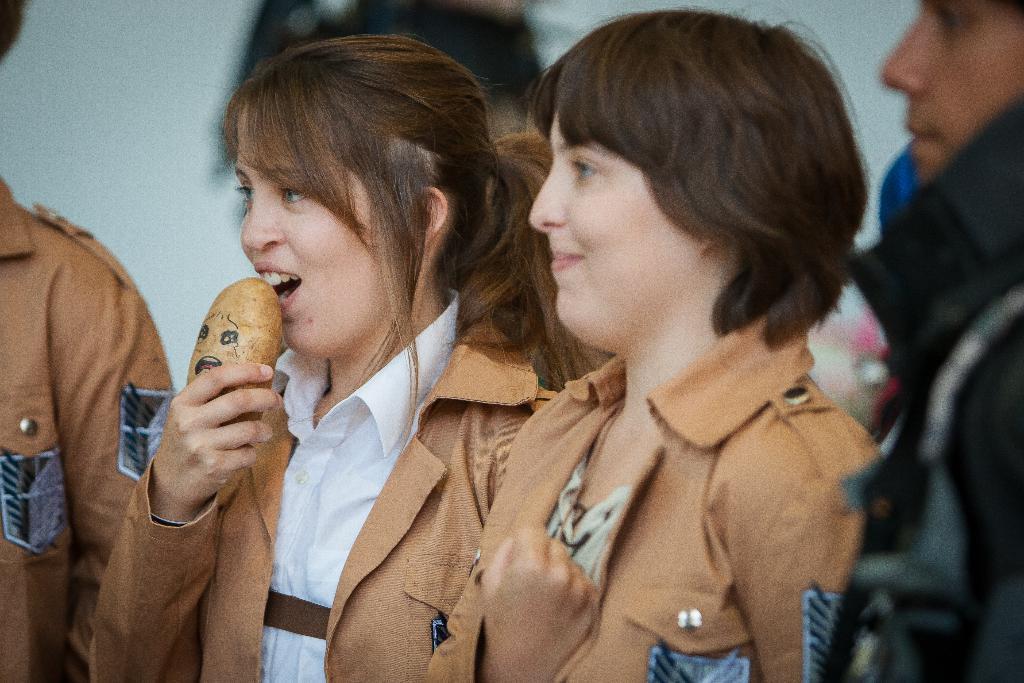Please provide a concise description of this image. In this image I can see the the group of people with black, white and brown color dresses. I can see one person holding the brown color object and there is a blurred background. 